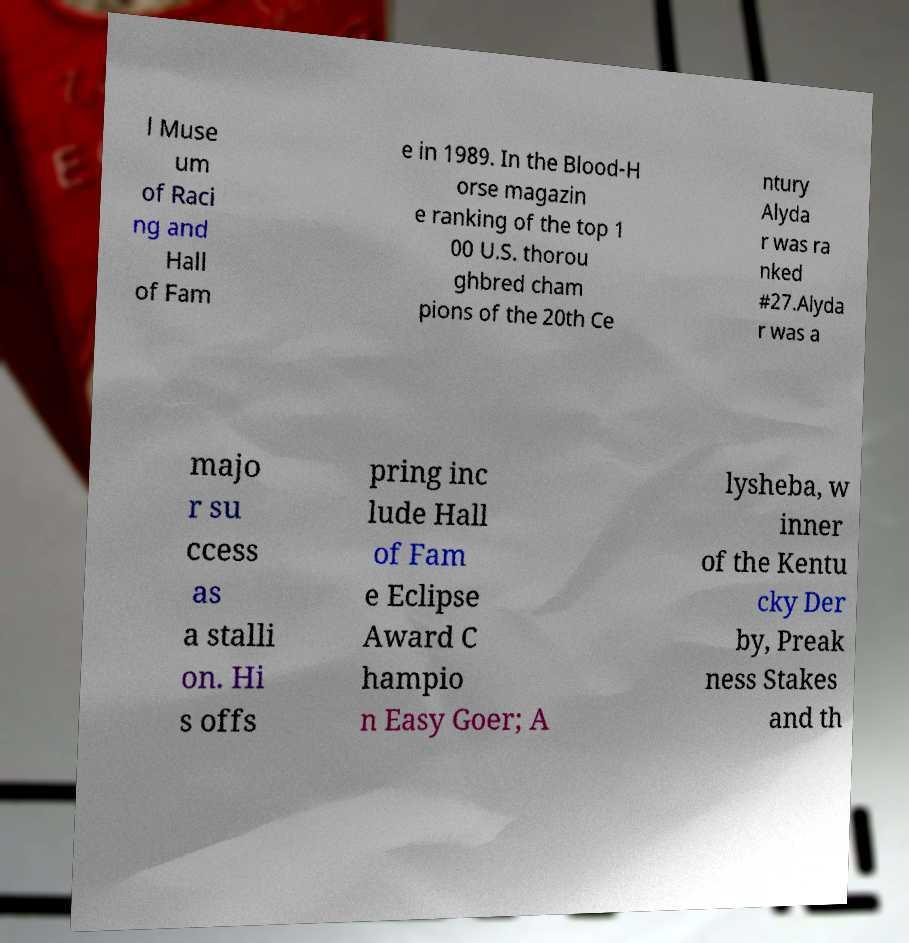Please read and relay the text visible in this image. What does it say? l Muse um of Raci ng and Hall of Fam e in 1989. In the Blood-H orse magazin e ranking of the top 1 00 U.S. thorou ghbred cham pions of the 20th Ce ntury Alyda r was ra nked #27.Alyda r was a majo r su ccess as a stalli on. Hi s offs pring inc lude Hall of Fam e Eclipse Award C hampio n Easy Goer; A lysheba, w inner of the Kentu cky Der by, Preak ness Stakes and th 